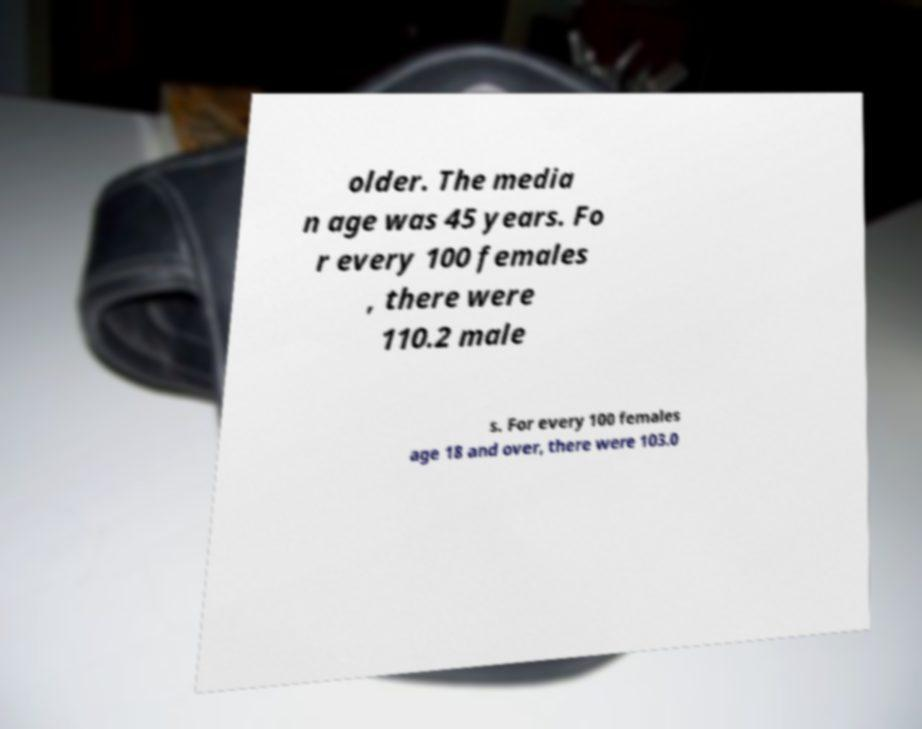I need the written content from this picture converted into text. Can you do that? older. The media n age was 45 years. Fo r every 100 females , there were 110.2 male s. For every 100 females age 18 and over, there were 103.0 